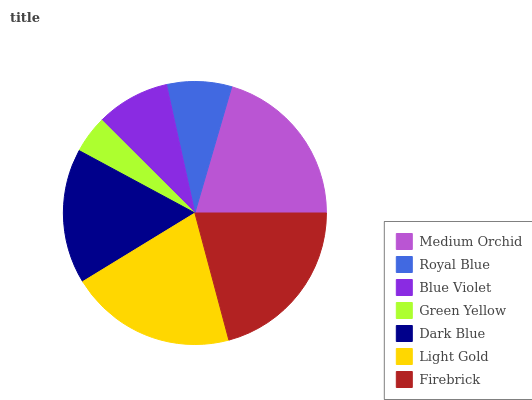Is Green Yellow the minimum?
Answer yes or no. Yes. Is Firebrick the maximum?
Answer yes or no. Yes. Is Royal Blue the minimum?
Answer yes or no. No. Is Royal Blue the maximum?
Answer yes or no. No. Is Medium Orchid greater than Royal Blue?
Answer yes or no. Yes. Is Royal Blue less than Medium Orchid?
Answer yes or no. Yes. Is Royal Blue greater than Medium Orchid?
Answer yes or no. No. Is Medium Orchid less than Royal Blue?
Answer yes or no. No. Is Dark Blue the high median?
Answer yes or no. Yes. Is Dark Blue the low median?
Answer yes or no. Yes. Is Royal Blue the high median?
Answer yes or no. No. Is Medium Orchid the low median?
Answer yes or no. No. 